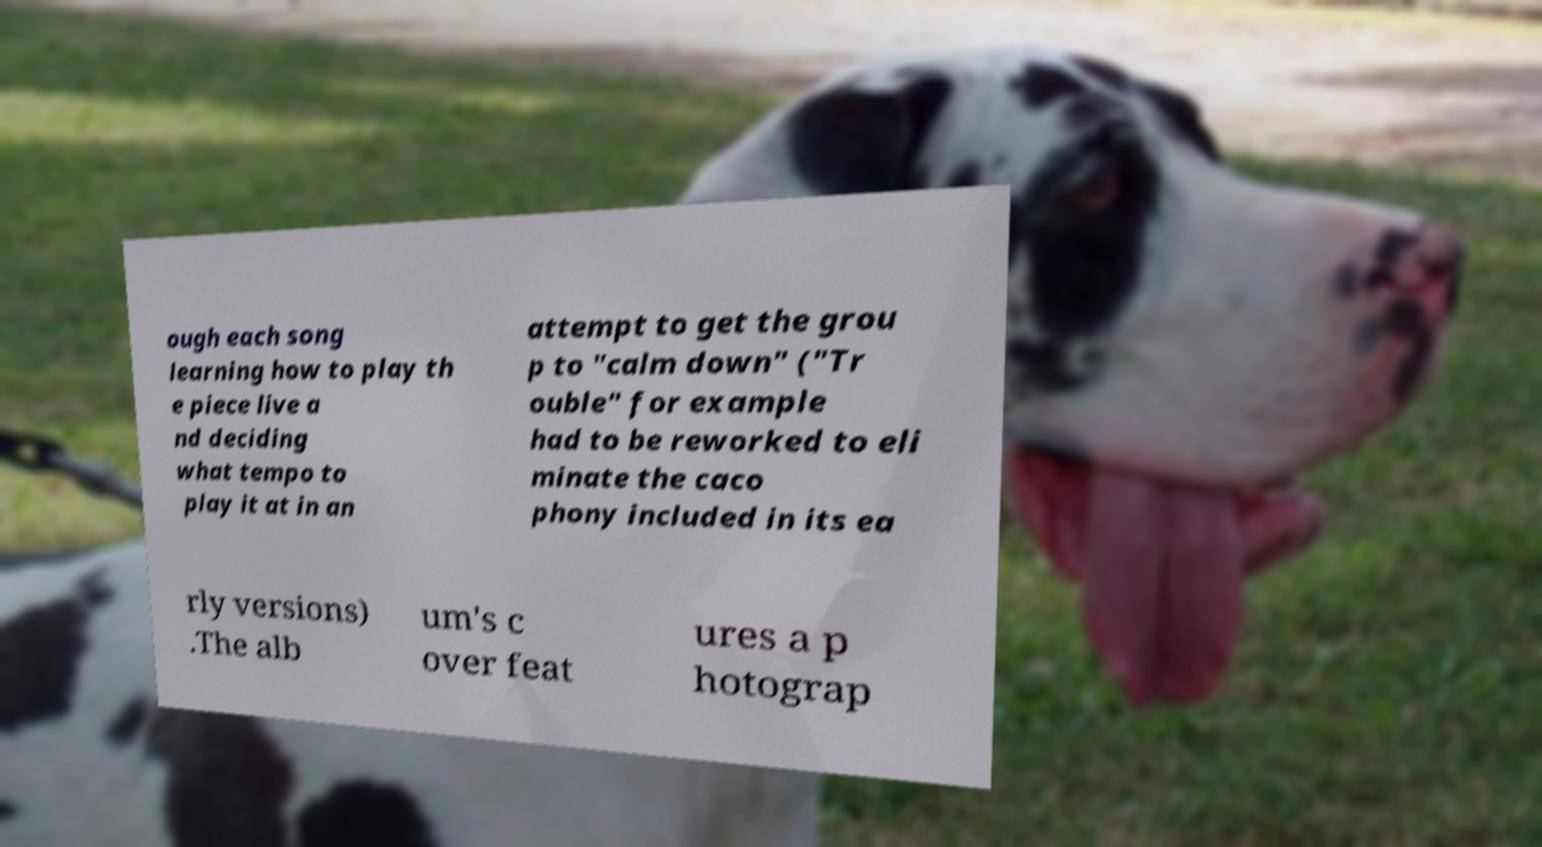Can you read and provide the text displayed in the image?This photo seems to have some interesting text. Can you extract and type it out for me? ough each song learning how to play th e piece live a nd deciding what tempo to play it at in an attempt to get the grou p to "calm down" ("Tr ouble" for example had to be reworked to eli minate the caco phony included in its ea rly versions) .The alb um's c over feat ures a p hotograp 